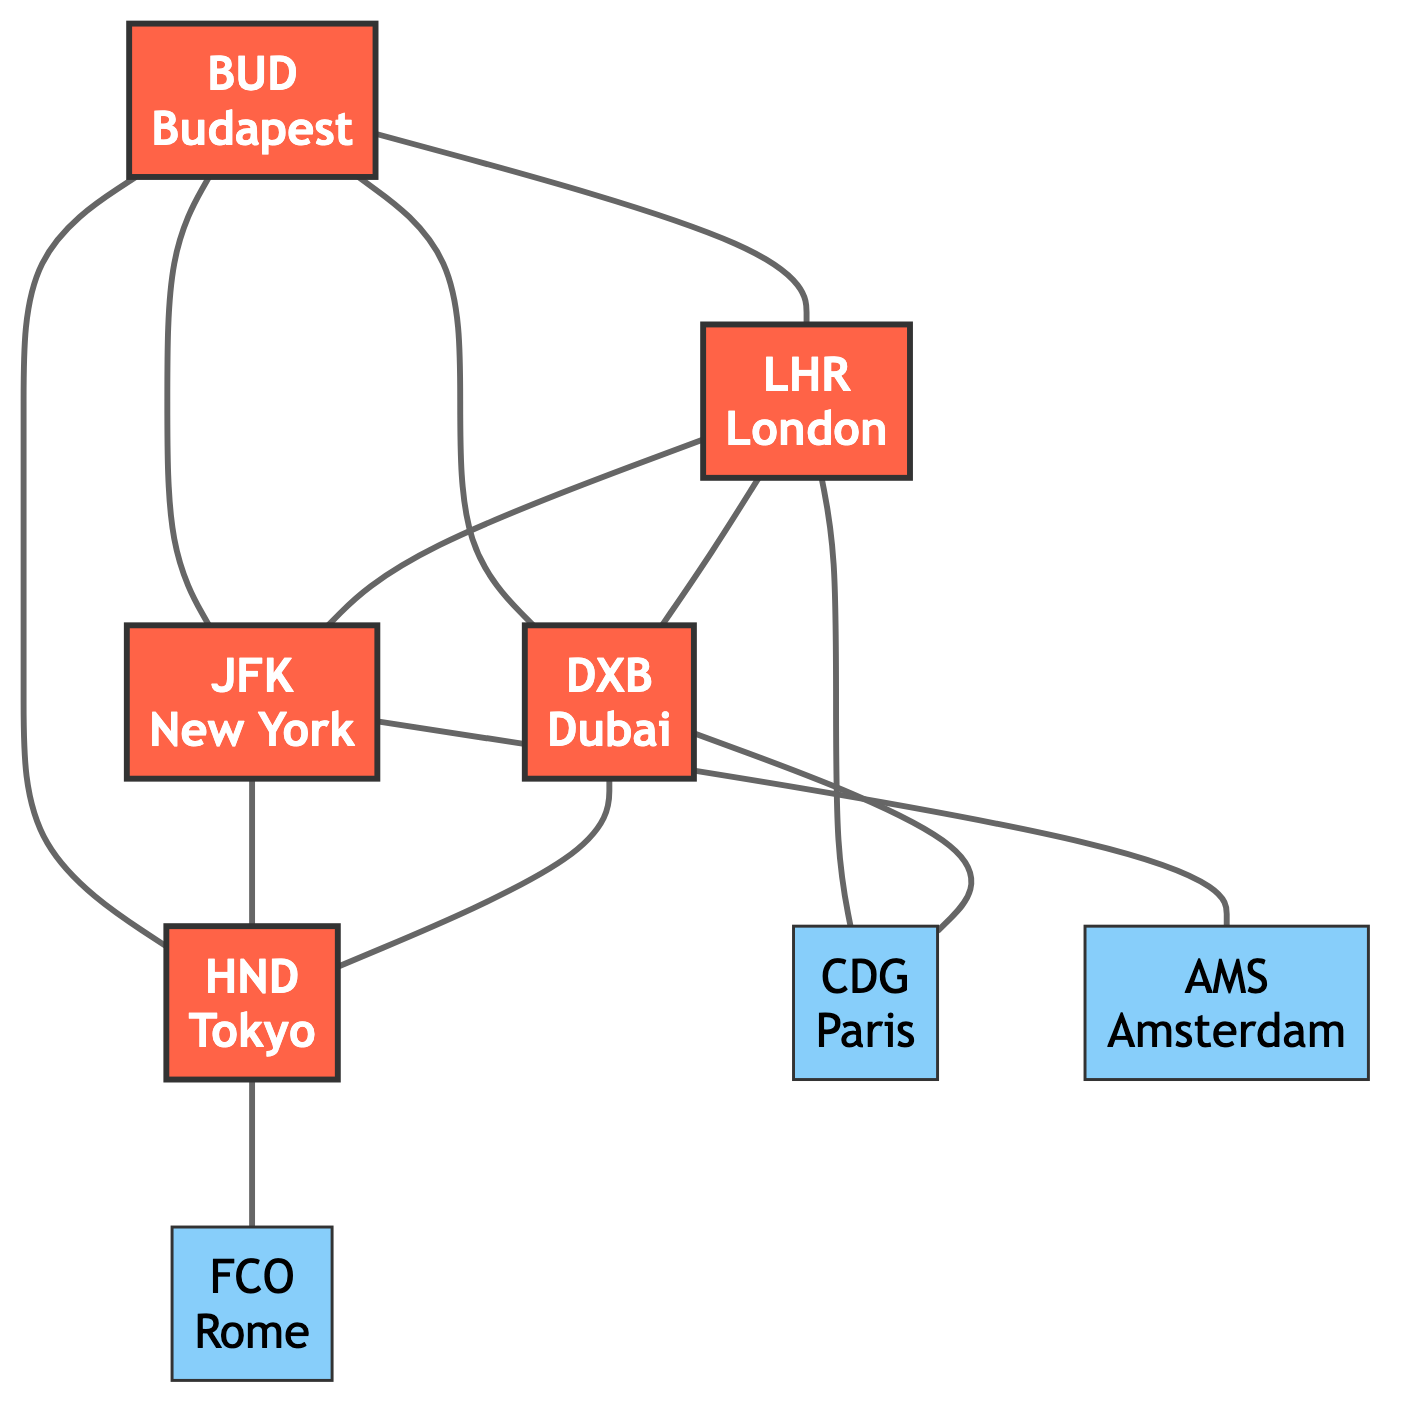What are the hub airports in this diagram? The diagram lists airport nodes identified as hubs. The hubs indicated are Budapest, London, New York, Dubai, and Tokyo.
Answer: Budapest, London, New York, Dubai, Tokyo How many connections are there from Budapest? To find this, count the number of edges (connections) that originate from the Budapest node. There are four connections: to London, New York, Dubai, and Tokyo.
Answer: 4 Which airport connects directly to the most locations? The airport with the most connections can be determined by counting the edges connected to each hub. London connects to three locations (New York, Dubai, Paris), while New York connects to two locations (Tokyo, Amsterdam). Thus, Budapest, with four connections, has the most.
Answer: Budapest Does Tokyo have connections to any non-hub airports? By examining Tokyo's connections, it shows an edge leading to Rome, which is a non-hub airport (FCO). Therefore, Tokyo has one connection that is to a non-hub airport.
Answer: Yes Which airport connects Budapest and Paris? To find this, look for a connection that leads from Budapest to the Paris airport. The only connection leading to Paris is from London, making that the answer.
Answer: London 